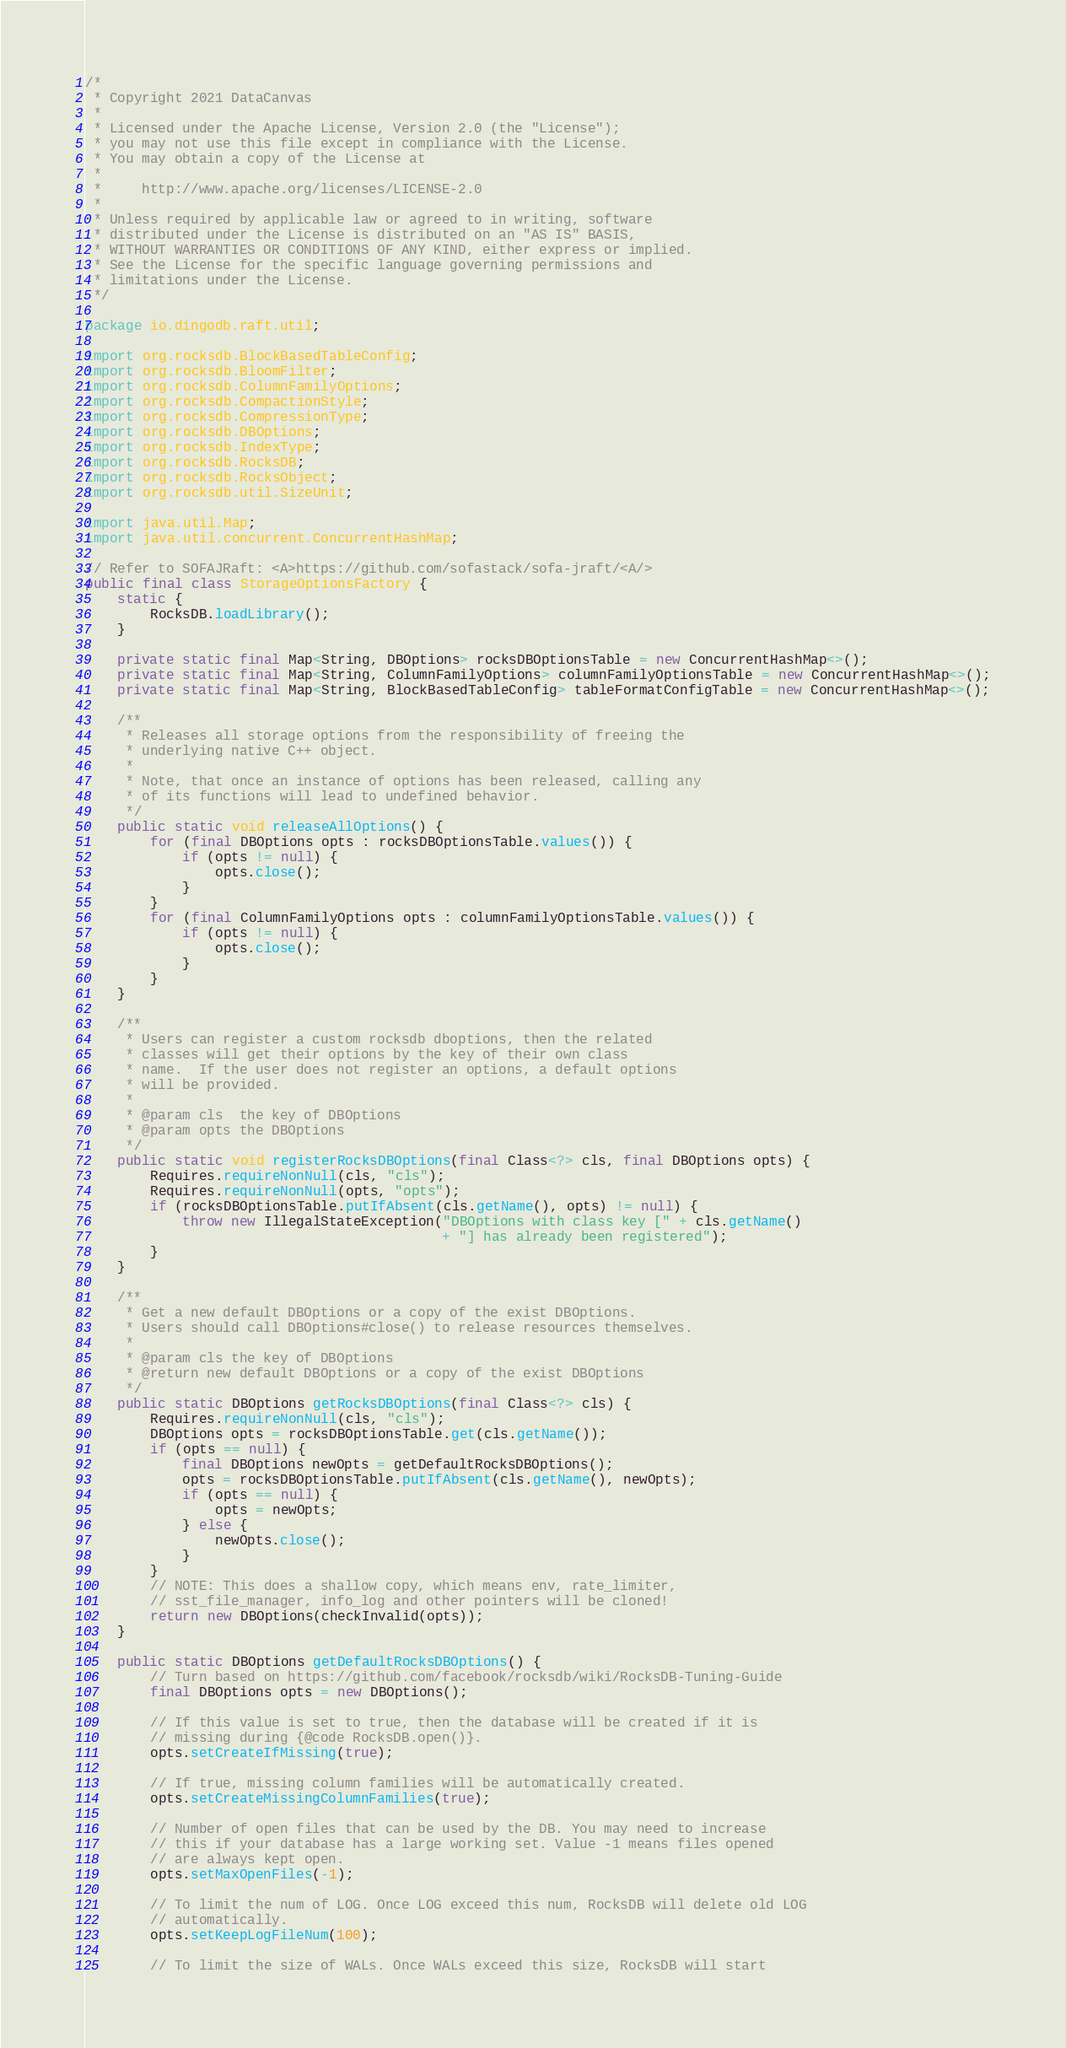Convert code to text. <code><loc_0><loc_0><loc_500><loc_500><_Java_>/*
 * Copyright 2021 DataCanvas
 *
 * Licensed under the Apache License, Version 2.0 (the "License");
 * you may not use this file except in compliance with the License.
 * You may obtain a copy of the License at
 *
 *     http://www.apache.org/licenses/LICENSE-2.0
 *
 * Unless required by applicable law or agreed to in writing, software
 * distributed under the License is distributed on an "AS IS" BASIS,
 * WITHOUT WARRANTIES OR CONDITIONS OF ANY KIND, either express or implied.
 * See the License for the specific language governing permissions and
 * limitations under the License.
 */

package io.dingodb.raft.util;

import org.rocksdb.BlockBasedTableConfig;
import org.rocksdb.BloomFilter;
import org.rocksdb.ColumnFamilyOptions;
import org.rocksdb.CompactionStyle;
import org.rocksdb.CompressionType;
import org.rocksdb.DBOptions;
import org.rocksdb.IndexType;
import org.rocksdb.RocksDB;
import org.rocksdb.RocksObject;
import org.rocksdb.util.SizeUnit;

import java.util.Map;
import java.util.concurrent.ConcurrentHashMap;

// Refer to SOFAJRaft: <A>https://github.com/sofastack/sofa-jraft/<A/>
public final class StorageOptionsFactory {
    static {
        RocksDB.loadLibrary();
    }

    private static final Map<String, DBOptions> rocksDBOptionsTable = new ConcurrentHashMap<>();
    private static final Map<String, ColumnFamilyOptions> columnFamilyOptionsTable = new ConcurrentHashMap<>();
    private static final Map<String, BlockBasedTableConfig> tableFormatConfigTable = new ConcurrentHashMap<>();

    /**
     * Releases all storage options from the responsibility of freeing the
     * underlying native C++ object.
     *
     * Note, that once an instance of options has been released, calling any
     * of its functions will lead to undefined behavior.
     */
    public static void releaseAllOptions() {
        for (final DBOptions opts : rocksDBOptionsTable.values()) {
            if (opts != null) {
                opts.close();
            }
        }
        for (final ColumnFamilyOptions opts : columnFamilyOptionsTable.values()) {
            if (opts != null) {
                opts.close();
            }
        }
    }

    /**
     * Users can register a custom rocksdb dboptions, then the related
     * classes will get their options by the key of their own class
     * name.  If the user does not register an options, a default options
     * will be provided.
     *
     * @param cls  the key of DBOptions
     * @param opts the DBOptions
     */
    public static void registerRocksDBOptions(final Class<?> cls, final DBOptions opts) {
        Requires.requireNonNull(cls, "cls");
        Requires.requireNonNull(opts, "opts");
        if (rocksDBOptionsTable.putIfAbsent(cls.getName(), opts) != null) {
            throw new IllegalStateException("DBOptions with class key [" + cls.getName()
                                            + "] has already been registered");
        }
    }

    /**
     * Get a new default DBOptions or a copy of the exist DBOptions.
     * Users should call DBOptions#close() to release resources themselves.
     *
     * @param cls the key of DBOptions
     * @return new default DBOptions or a copy of the exist DBOptions
     */
    public static DBOptions getRocksDBOptions(final Class<?> cls) {
        Requires.requireNonNull(cls, "cls");
        DBOptions opts = rocksDBOptionsTable.get(cls.getName());
        if (opts == null) {
            final DBOptions newOpts = getDefaultRocksDBOptions();
            opts = rocksDBOptionsTable.putIfAbsent(cls.getName(), newOpts);
            if (opts == null) {
                opts = newOpts;
            } else {
                newOpts.close();
            }
        }
        // NOTE: This does a shallow copy, which means env, rate_limiter,
        // sst_file_manager, info_log and other pointers will be cloned!
        return new DBOptions(checkInvalid(opts));
    }

    public static DBOptions getDefaultRocksDBOptions() {
        // Turn based on https://github.com/facebook/rocksdb/wiki/RocksDB-Tuning-Guide
        final DBOptions opts = new DBOptions();

        // If this value is set to true, then the database will be created if it is
        // missing during {@code RocksDB.open()}.
        opts.setCreateIfMissing(true);

        // If true, missing column families will be automatically created.
        opts.setCreateMissingColumnFamilies(true);

        // Number of open files that can be used by the DB. You may need to increase
        // this if your database has a large working set. Value -1 means files opened
        // are always kept open.
        opts.setMaxOpenFiles(-1);

        // To limit the num of LOG. Once LOG exceed this num, RocksDB will delete old LOG
        // automatically.
        opts.setKeepLogFileNum(100);

        // To limit the size of WALs. Once WALs exceed this size, RocksDB will start</code> 